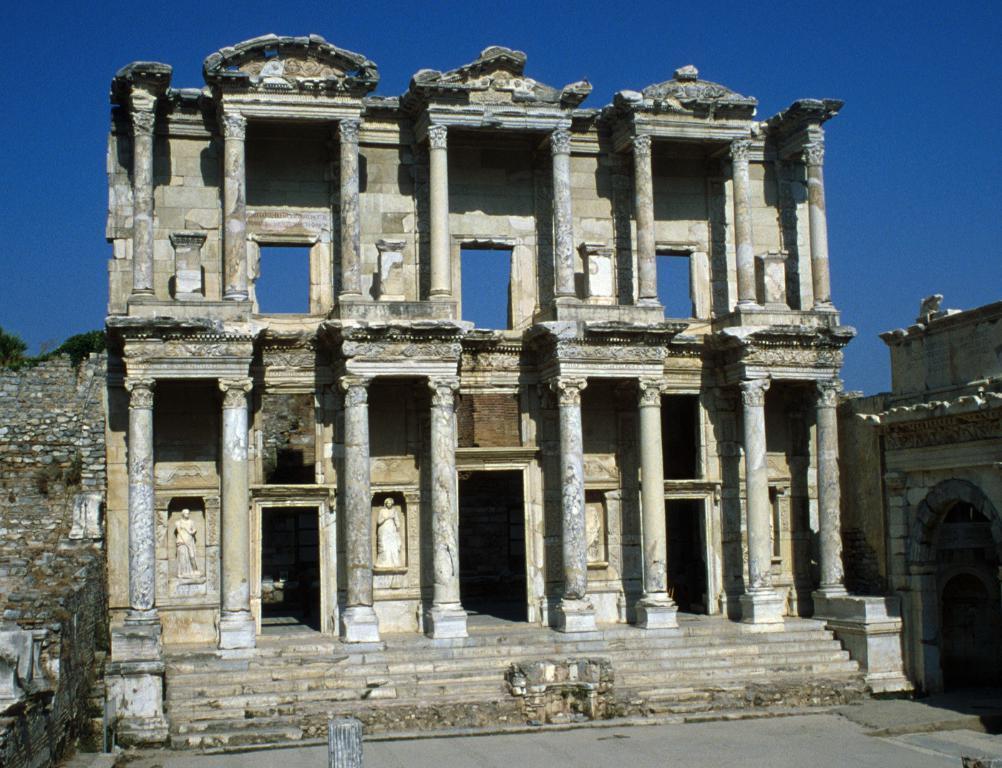Please provide a concise description of this image. This image consists of a building which consists of pillars and walls. At the top, there is a sky in blue color. At the bottom, there is ground. 